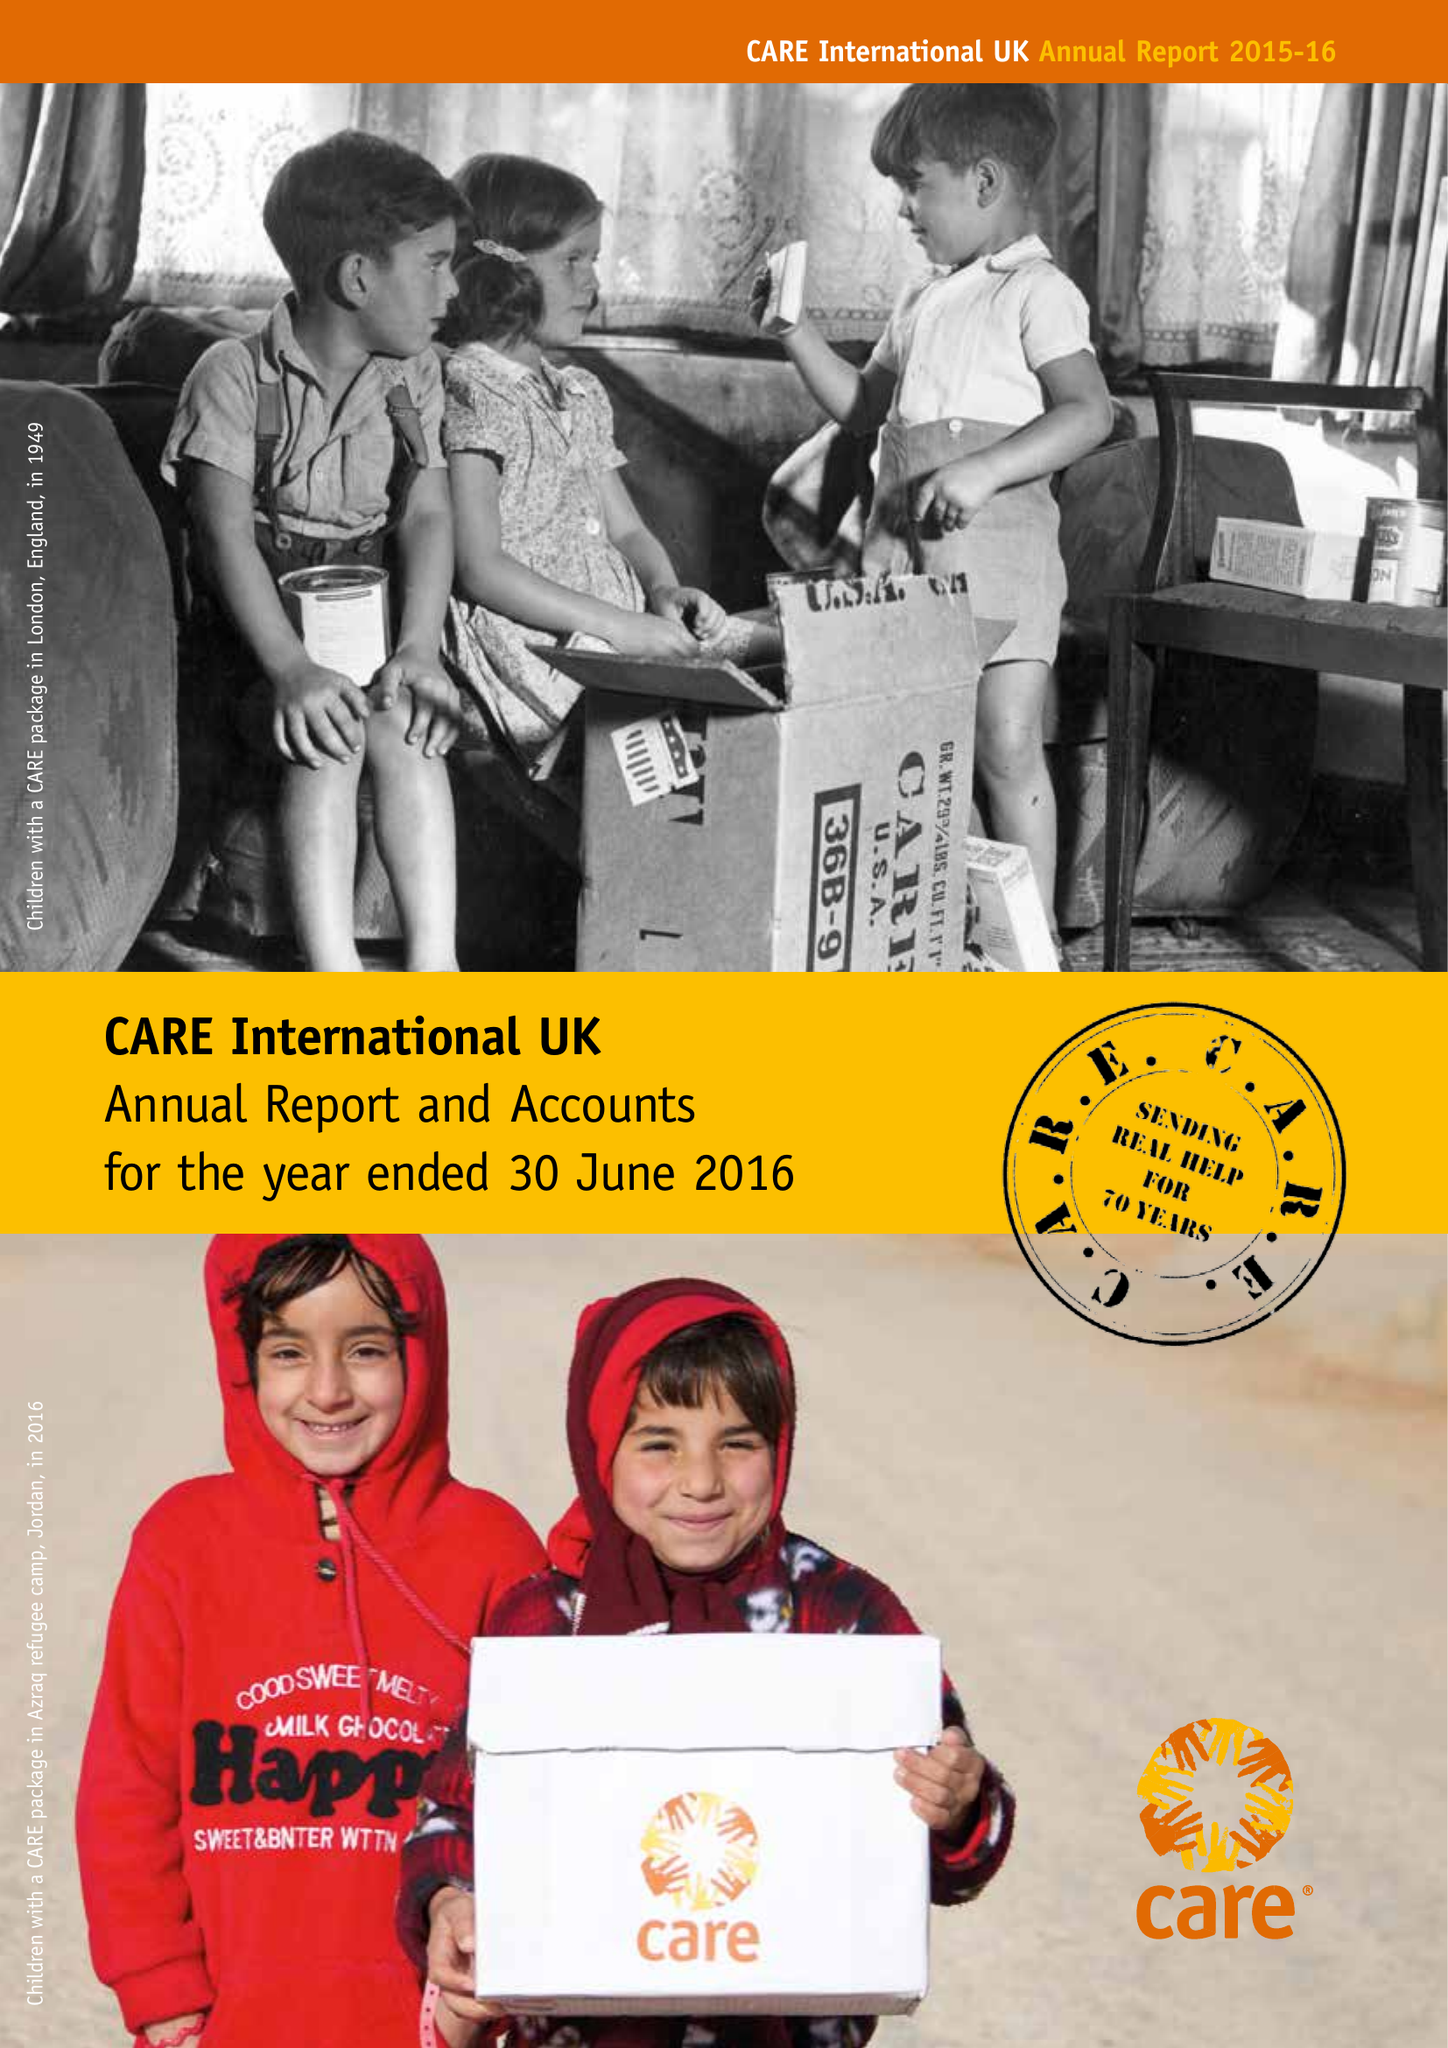What is the value for the address__street_line?
Answer the question using a single word or phrase. 87-90 ALBERT EMBANKMENT 